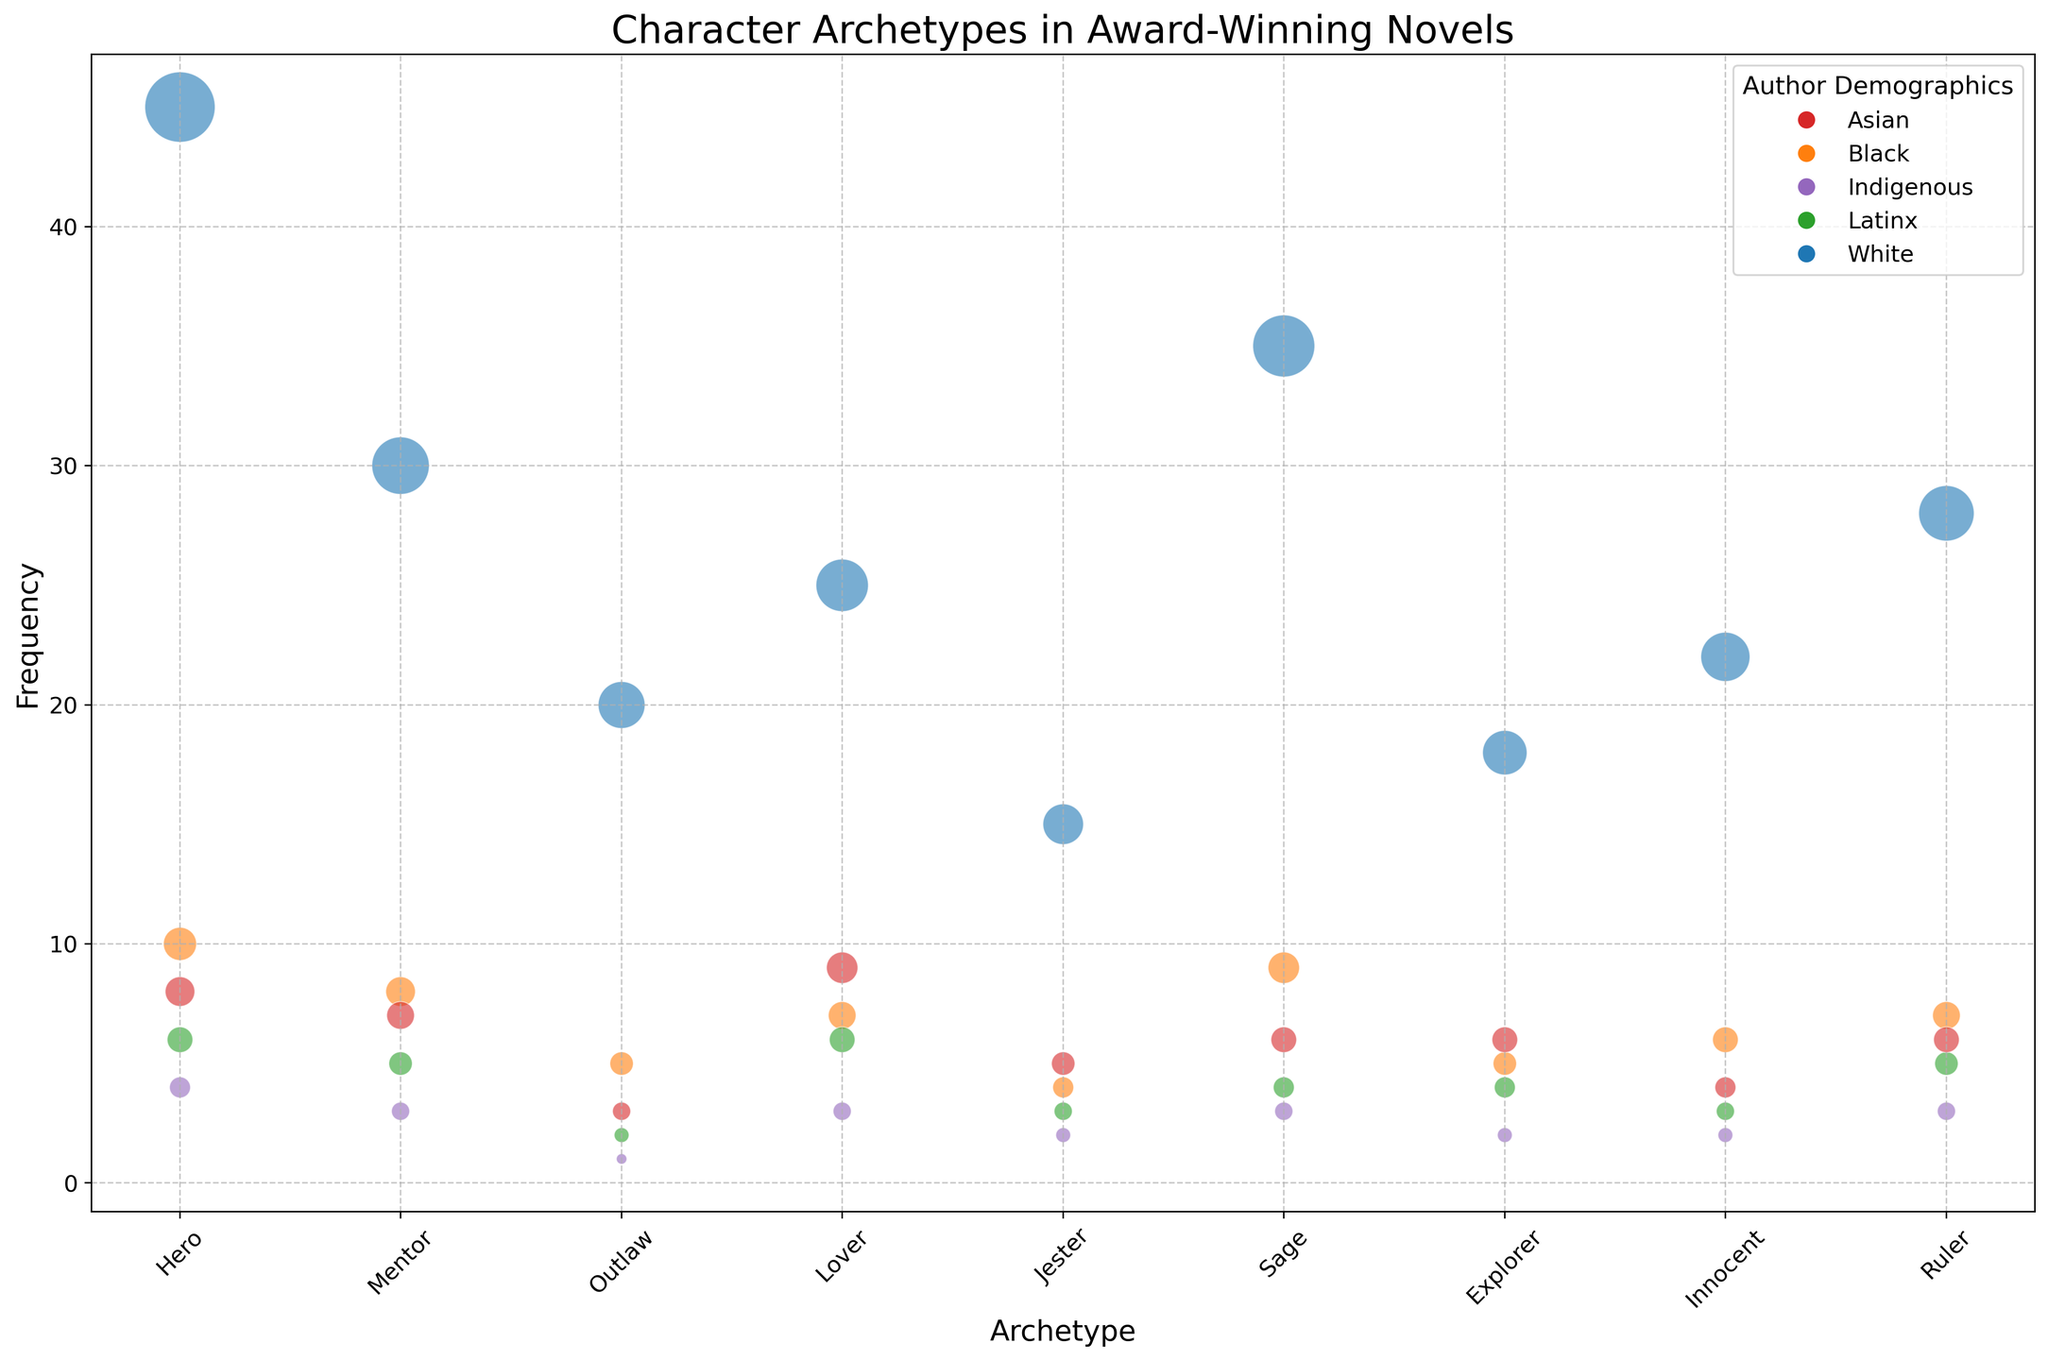Which character archetype has the highest frequency among award-winning novels? The "Hero" archetype has the highest frequency among the provided data points.
Answer: Hero How many times does the "Sage" archetype appear in novels written by Black authors? The bubble chart shows that the "Sage" archetype appears 9 times in novels written by Black authors, indicated by orange bubbles with the corresponding frequency.
Answer: 9 What is the total frequency of the "Hero" archetype across all author demographics? Add the frequencies for the "Hero" archetype across all demographics: 45 (White) + 10 (Black) + 6 (Latinx) + 8 (Asian) + 4 (Indigenous) = 73.
Answer: 73 Which author demographic is responsible for the highest number of "Lover" archetypes in the novels? The white bubble for the "Lover" archetype is the largest, indicating that authors from the White demographic have the highest frequency of "Lover" characters at 25.
Answer: White Compare the frequency of the "Innocent" archetype in novels written by Latinx and Indigenous authors. Which is higher, and by how much? The frequency for the "Innocent" archetype is 3 for Latinx and 2 for Indigenous. The difference is 1.
Answer: Latinx, by 1 What is the average frequency of the "Mentor" archetype across all author demographics? Sum the frequencies: 30 (White) + 8 (Black) + 5 (Latinx) + 7 (Asian) + 3 (Indigenous) = 53. Divide by the number of demographics, which is 5. So, 53 / 5 = 10.6.
Answer: 10.6 Which character archetype appears equally frequently in the works of both Asian and Indigenous authors? The "Jester" archetype appears 5 times in novels by Asian authors and 5 times by Indigenous authors.
Answer: Jester What is the difference in frequency between the "Ruler" archetype by White authors and Black authors? The frequency of the "Ruler" archetype is 28 for White authors and 7 for Black authors. The difference is 28 - 7 = 21.
Answer: 21 How many character archetypes have a higher frequency of appearance in novels by White authors compared to Asian authors? Compare frequencies for each archetype. "Hero" (45>8), "Mentor" (30>7), "Outlaw" (20>3), "Lover" (25>9), "Jester" (15>5), "Sage" (35>6), "Explorer" (18>6), "Innocent" (22>4), and "Ruler" (28>6). All archetypes (9) have higher frequencies in novels by White authors.
Answer: 9 Compare the frequency of the "Outlaw" archetype between White and Latinx authors. Which is higher, and by how much? The frequency for the "Outlaw" archetype is 20 for White authors and 2 for Latinx authors. The difference is 20 - 2 = 18.
Answer: White, by 18 